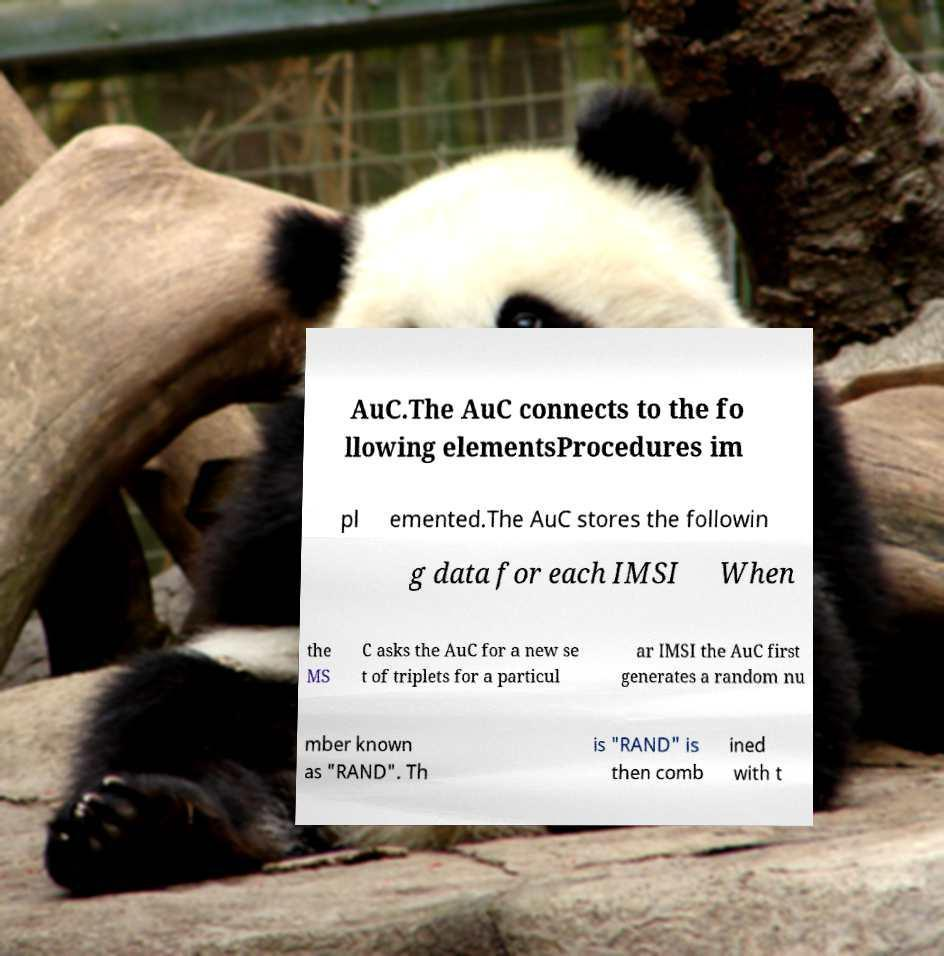Could you assist in decoding the text presented in this image and type it out clearly? AuC.The AuC connects to the fo llowing elementsProcedures im pl emented.The AuC stores the followin g data for each IMSI When the MS C asks the AuC for a new se t of triplets for a particul ar IMSI the AuC first generates a random nu mber known as "RAND". Th is "RAND" is then comb ined with t 